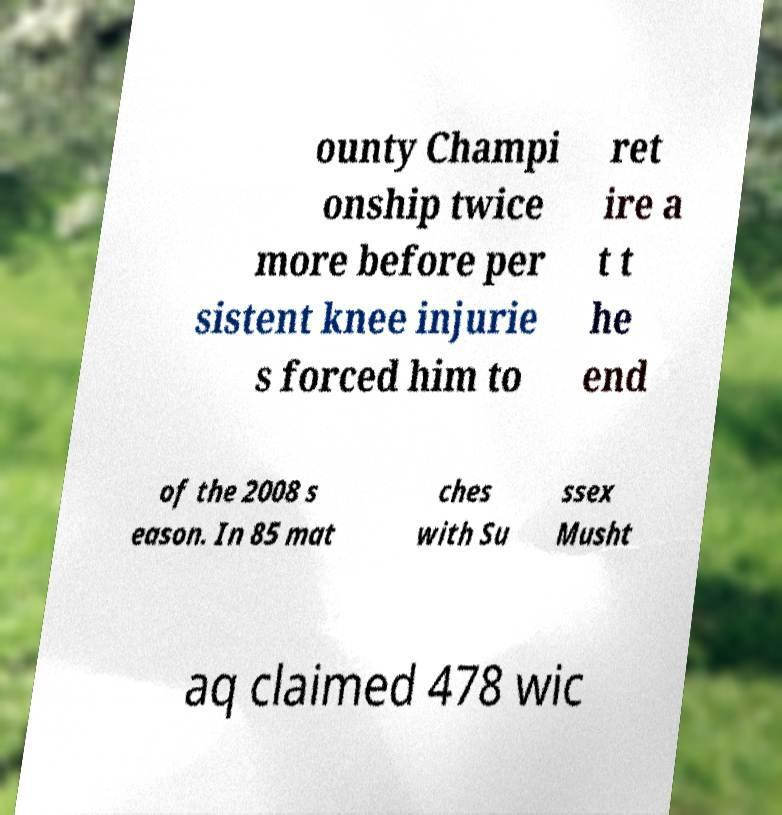There's text embedded in this image that I need extracted. Can you transcribe it verbatim? ounty Champi onship twice more before per sistent knee injurie s forced him to ret ire a t t he end of the 2008 s eason. In 85 mat ches with Su ssex Musht aq claimed 478 wic 